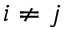Convert formula to latex. <formula><loc_0><loc_0><loc_500><loc_500>i \neq j</formula> 